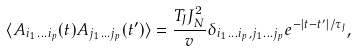<formula> <loc_0><loc_0><loc_500><loc_500>\langle A _ { i _ { 1 } \dots i _ { p } } ( t ) A _ { j _ { 1 } \dots j _ { p } } ( t ^ { \prime } ) \rangle = \frac { T _ { J } J _ { N } ^ { 2 } } { v } \delta _ { i _ { 1 } \dots i _ { p } , j _ { 1 } \dots j _ { p } } e ^ { - | t - t ^ { \prime } | / \tau _ { J } } ,</formula> 